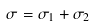Convert formula to latex. <formula><loc_0><loc_0><loc_500><loc_500>\sigma = \sigma _ { 1 } + \sigma _ { 2 }</formula> 